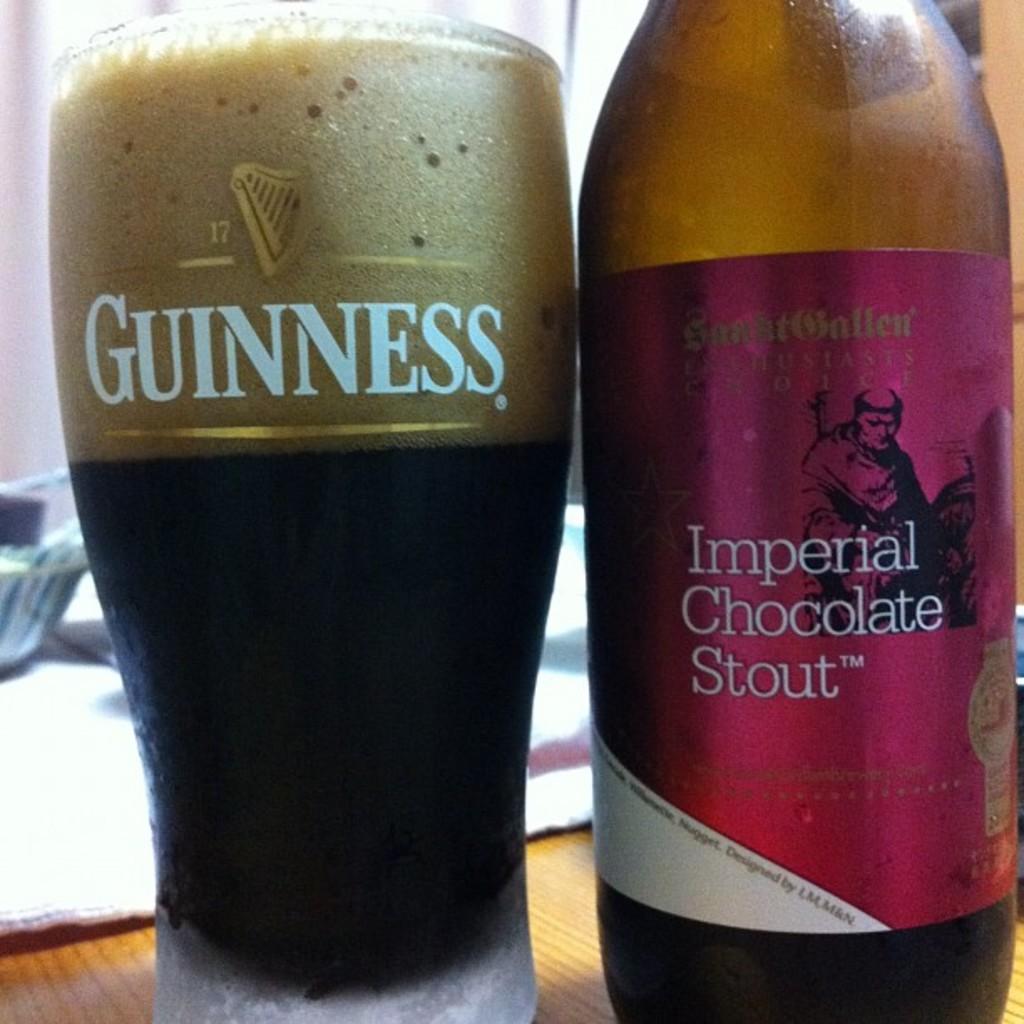What type of beer is in the bottle?
Your response must be concise. Imperial chocolate stout. 